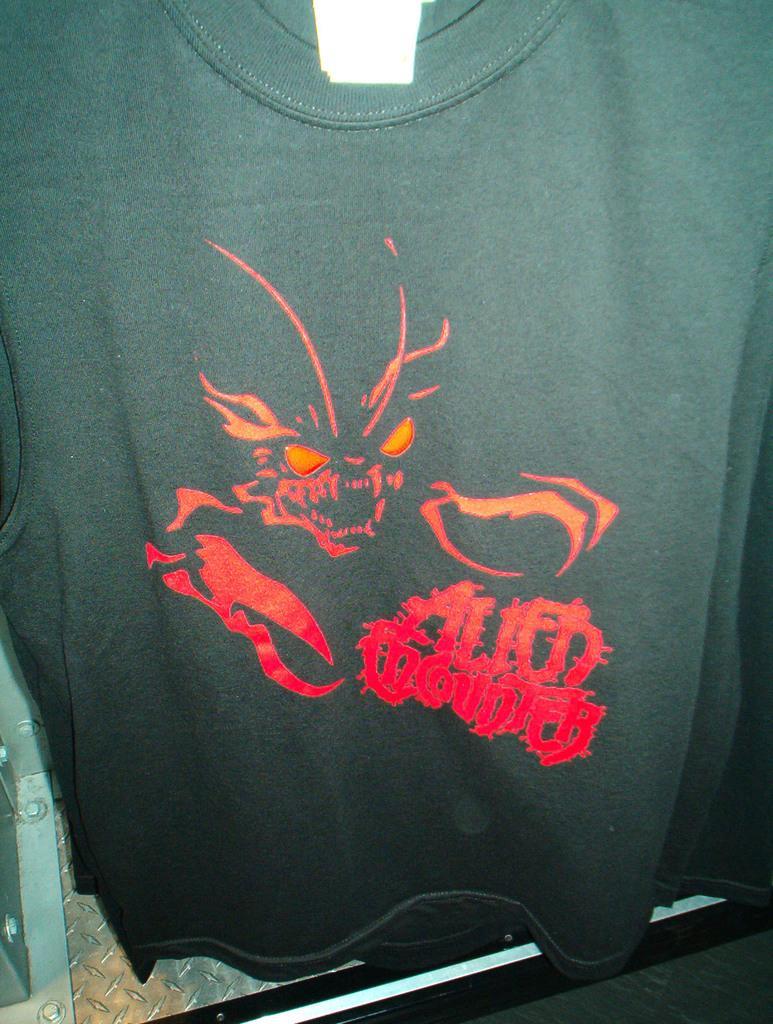Please provide a concise description of this image. We can see a black color t-shirt and in it there is a ghost picture and text written on it. On the left at the bottom there is a metal object. 